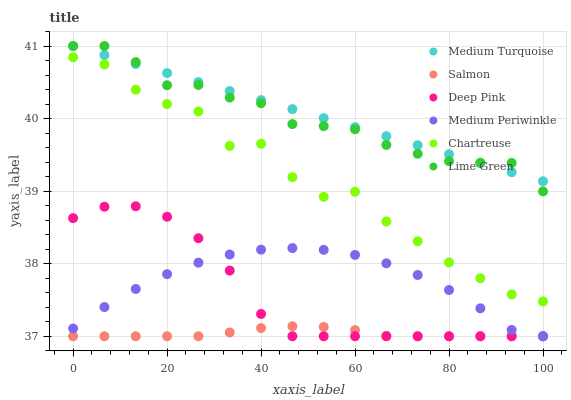Does Salmon have the minimum area under the curve?
Answer yes or no. Yes. Does Medium Turquoise have the maximum area under the curve?
Answer yes or no. Yes. Does Medium Periwinkle have the minimum area under the curve?
Answer yes or no. No. Does Medium Periwinkle have the maximum area under the curve?
Answer yes or no. No. Is Medium Turquoise the smoothest?
Answer yes or no. Yes. Is Chartreuse the roughest?
Answer yes or no. Yes. Is Salmon the smoothest?
Answer yes or no. No. Is Salmon the roughest?
Answer yes or no. No. Does Deep Pink have the lowest value?
Answer yes or no. Yes. Does Chartreuse have the lowest value?
Answer yes or no. No. Does Lime Green have the highest value?
Answer yes or no. Yes. Does Medium Periwinkle have the highest value?
Answer yes or no. No. Is Medium Periwinkle less than Chartreuse?
Answer yes or no. Yes. Is Medium Turquoise greater than Deep Pink?
Answer yes or no. Yes. Does Medium Turquoise intersect Lime Green?
Answer yes or no. Yes. Is Medium Turquoise less than Lime Green?
Answer yes or no. No. Is Medium Turquoise greater than Lime Green?
Answer yes or no. No. Does Medium Periwinkle intersect Chartreuse?
Answer yes or no. No. 